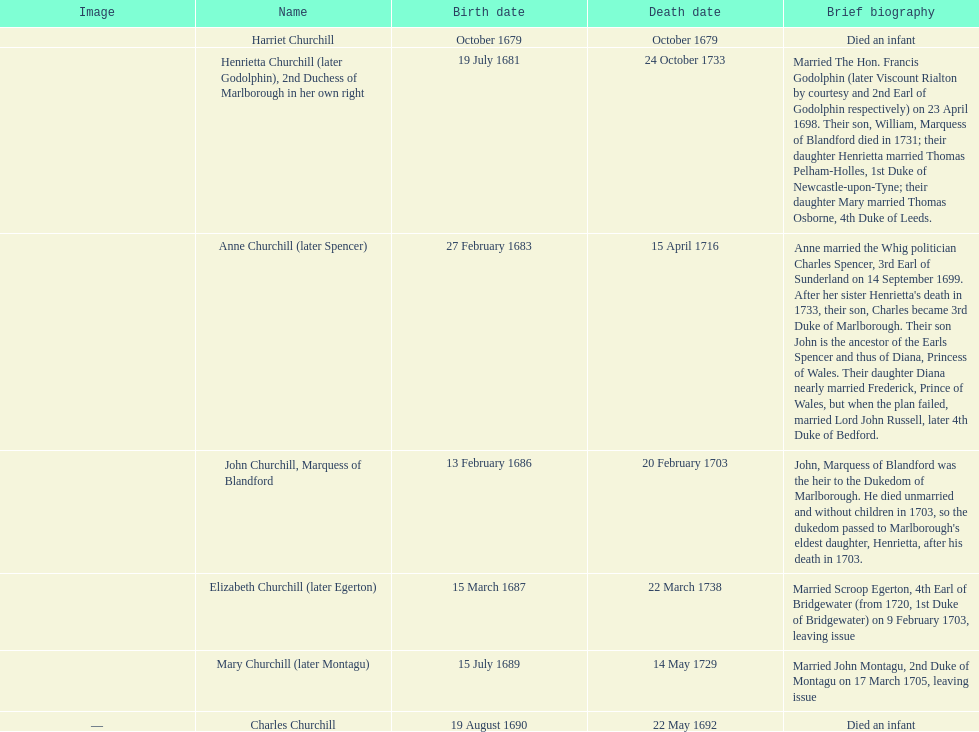Between mary churchill and elizabeth churchill, who was born earlier? Elizabeth Churchill. 